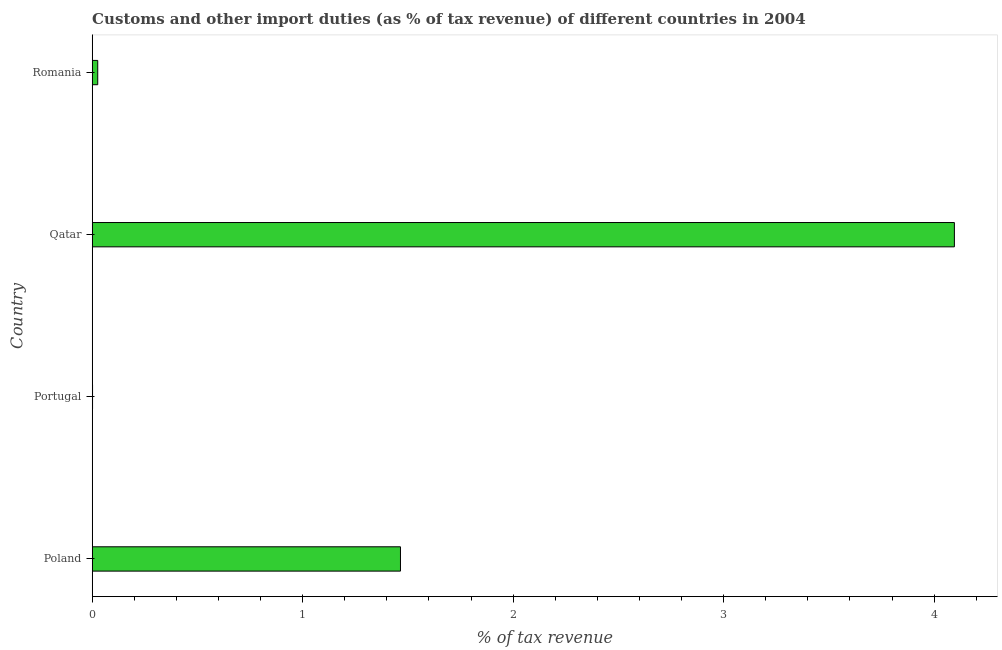Does the graph contain any zero values?
Your answer should be very brief. No. Does the graph contain grids?
Your response must be concise. No. What is the title of the graph?
Provide a short and direct response. Customs and other import duties (as % of tax revenue) of different countries in 2004. What is the label or title of the X-axis?
Ensure brevity in your answer.  % of tax revenue. What is the label or title of the Y-axis?
Your answer should be compact. Country. What is the customs and other import duties in Qatar?
Your response must be concise. 4.1. Across all countries, what is the maximum customs and other import duties?
Your answer should be very brief. 4.1. Across all countries, what is the minimum customs and other import duties?
Your answer should be very brief. 0. In which country was the customs and other import duties maximum?
Make the answer very short. Qatar. What is the sum of the customs and other import duties?
Provide a succinct answer. 5.59. What is the difference between the customs and other import duties in Portugal and Romania?
Your answer should be compact. -0.03. What is the average customs and other import duties per country?
Make the answer very short. 1.4. What is the median customs and other import duties?
Offer a very short reply. 0.75. In how many countries, is the customs and other import duties greater than 1.2 %?
Provide a succinct answer. 2. What is the ratio of the customs and other import duties in Portugal to that in Romania?
Provide a succinct answer. 0.06. What is the difference between the highest and the second highest customs and other import duties?
Your answer should be very brief. 2.63. What is the difference between the highest and the lowest customs and other import duties?
Make the answer very short. 4.09. How many bars are there?
Provide a succinct answer. 4. Are all the bars in the graph horizontal?
Ensure brevity in your answer.  Yes. Are the values on the major ticks of X-axis written in scientific E-notation?
Keep it short and to the point. No. What is the % of tax revenue of Poland?
Your answer should be very brief. 1.46. What is the % of tax revenue in Portugal?
Make the answer very short. 0. What is the % of tax revenue of Qatar?
Provide a short and direct response. 4.1. What is the % of tax revenue in Romania?
Provide a succinct answer. 0.03. What is the difference between the % of tax revenue in Poland and Portugal?
Your response must be concise. 1.46. What is the difference between the % of tax revenue in Poland and Qatar?
Ensure brevity in your answer.  -2.63. What is the difference between the % of tax revenue in Poland and Romania?
Keep it short and to the point. 1.44. What is the difference between the % of tax revenue in Portugal and Qatar?
Offer a very short reply. -4.09. What is the difference between the % of tax revenue in Portugal and Romania?
Provide a short and direct response. -0.02. What is the difference between the % of tax revenue in Qatar and Romania?
Offer a terse response. 4.07. What is the ratio of the % of tax revenue in Poland to that in Portugal?
Ensure brevity in your answer.  1013.53. What is the ratio of the % of tax revenue in Poland to that in Qatar?
Make the answer very short. 0.36. What is the ratio of the % of tax revenue in Poland to that in Romania?
Keep it short and to the point. 56.09. What is the ratio of the % of tax revenue in Portugal to that in Qatar?
Keep it short and to the point. 0. What is the ratio of the % of tax revenue in Portugal to that in Romania?
Offer a very short reply. 0.06. What is the ratio of the % of tax revenue in Qatar to that in Romania?
Provide a succinct answer. 156.89. 